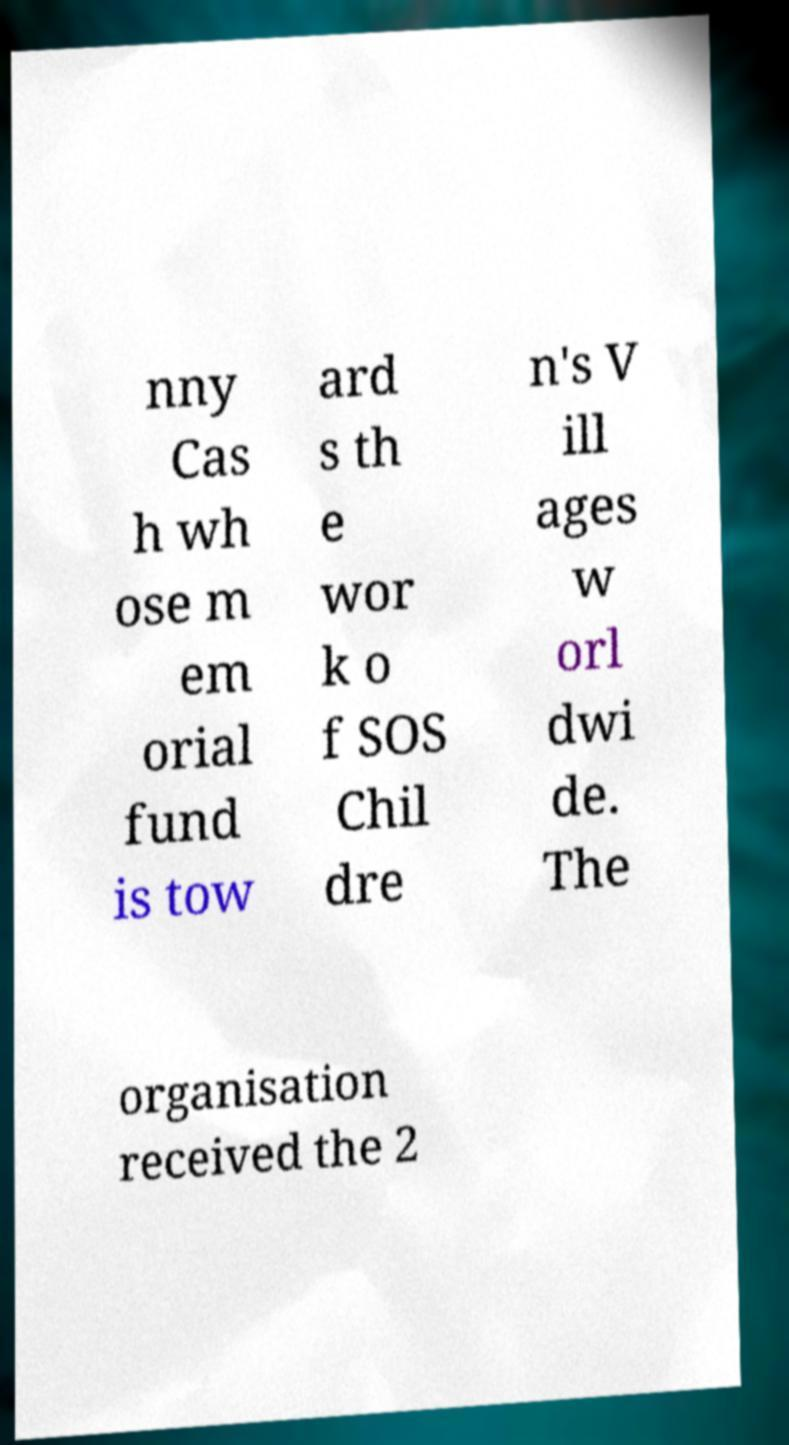Can you read and provide the text displayed in the image?This photo seems to have some interesting text. Can you extract and type it out for me? nny Cas h wh ose m em orial fund is tow ard s th e wor k o f SOS Chil dre n's V ill ages w orl dwi de. The organisation received the 2 